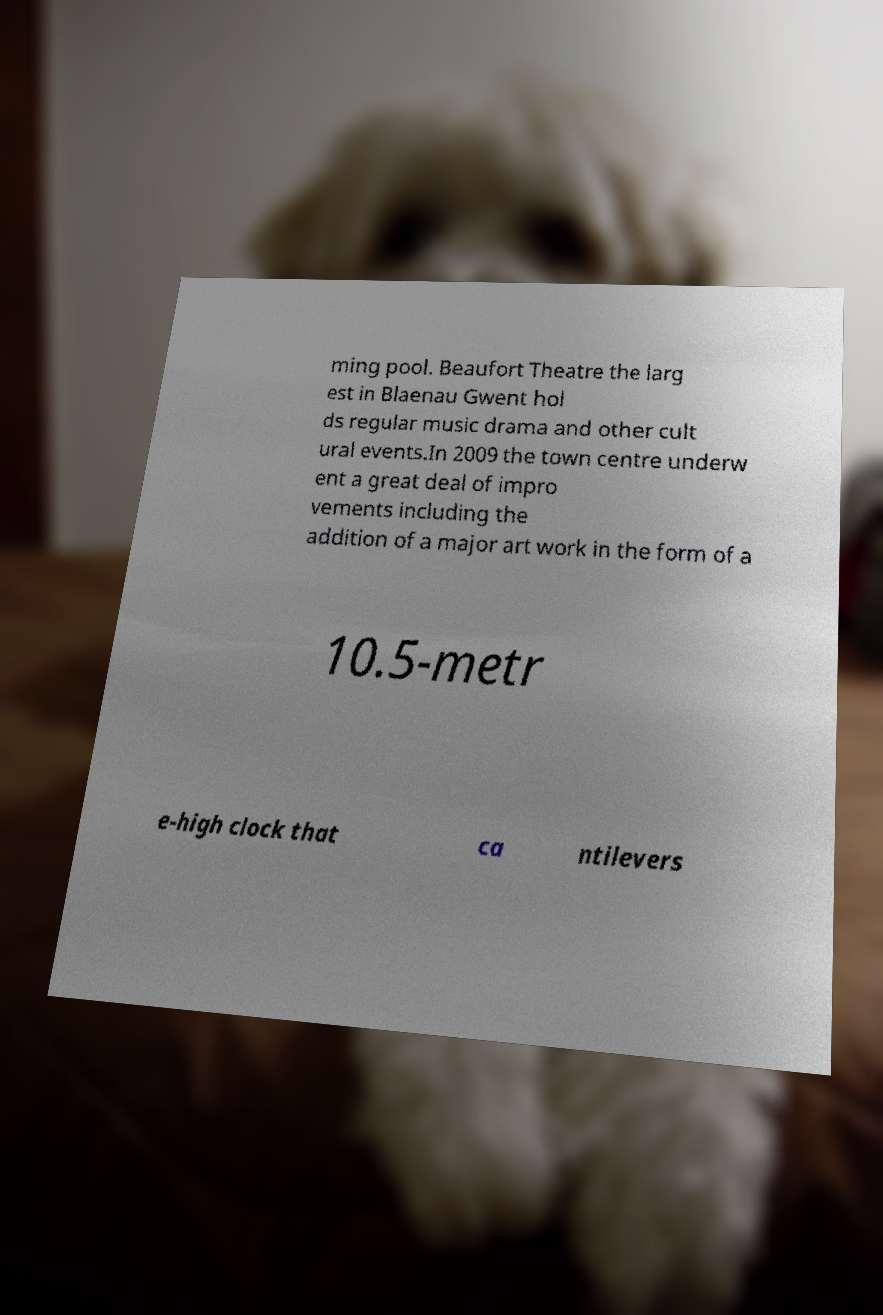Please read and relay the text visible in this image. What does it say? ming pool. Beaufort Theatre the larg est in Blaenau Gwent hol ds regular music drama and other cult ural events.In 2009 the town centre underw ent a great deal of impro vements including the addition of a major art work in the form of a 10.5-metr e-high clock that ca ntilevers 